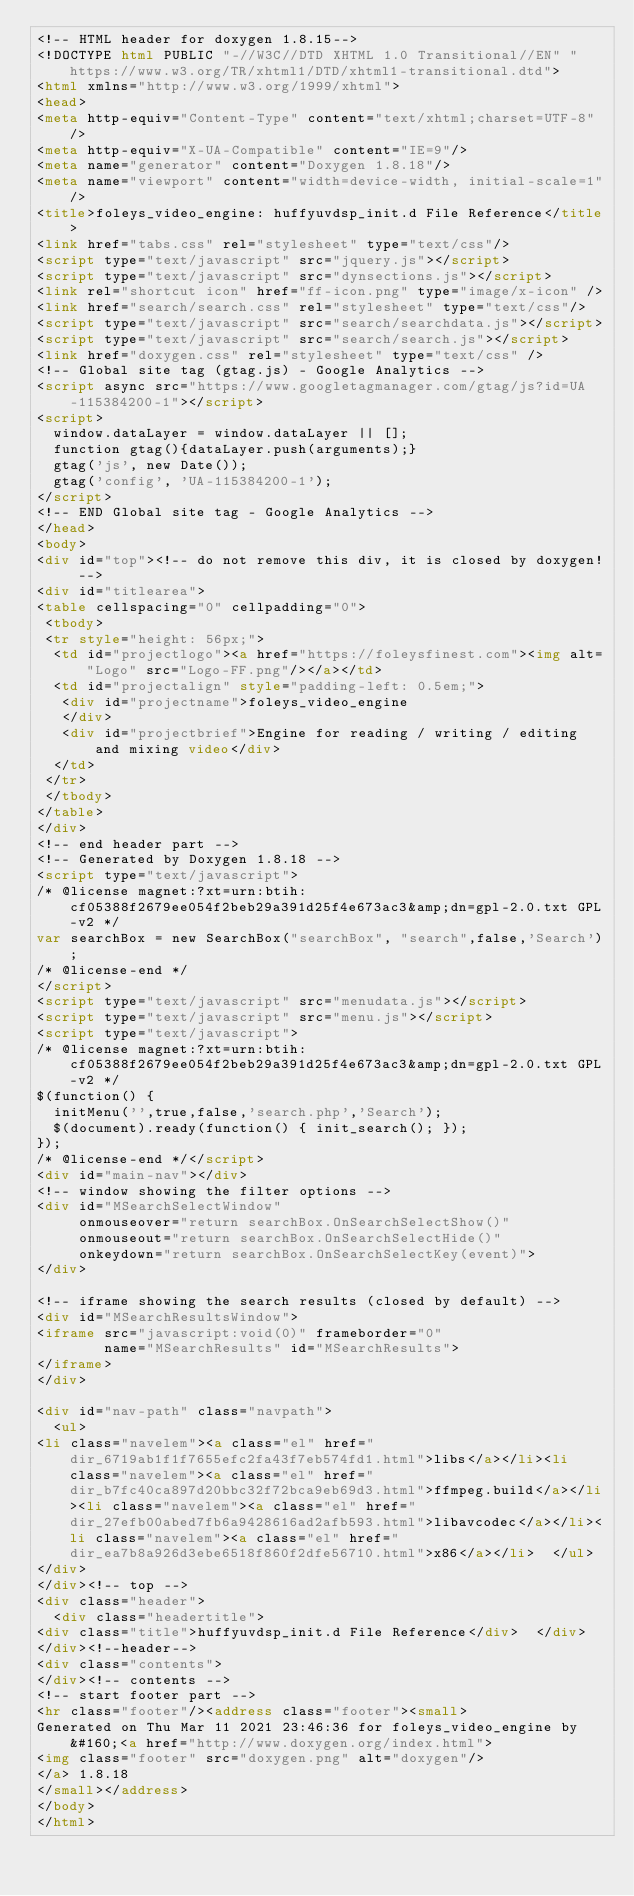Convert code to text. <code><loc_0><loc_0><loc_500><loc_500><_HTML_><!-- HTML header for doxygen 1.8.15-->
<!DOCTYPE html PUBLIC "-//W3C//DTD XHTML 1.0 Transitional//EN" "https://www.w3.org/TR/xhtml1/DTD/xhtml1-transitional.dtd">
<html xmlns="http://www.w3.org/1999/xhtml">
<head>
<meta http-equiv="Content-Type" content="text/xhtml;charset=UTF-8"/>
<meta http-equiv="X-UA-Compatible" content="IE=9"/>
<meta name="generator" content="Doxygen 1.8.18"/>
<meta name="viewport" content="width=device-width, initial-scale=1"/>
<title>foleys_video_engine: huffyuvdsp_init.d File Reference</title>
<link href="tabs.css" rel="stylesheet" type="text/css"/>
<script type="text/javascript" src="jquery.js"></script>
<script type="text/javascript" src="dynsections.js"></script>
<link rel="shortcut icon" href="ff-icon.png" type="image/x-icon" />
<link href="search/search.css" rel="stylesheet" type="text/css"/>
<script type="text/javascript" src="search/searchdata.js"></script>
<script type="text/javascript" src="search/search.js"></script>
<link href="doxygen.css" rel="stylesheet" type="text/css" />
<!-- Global site tag (gtag.js) - Google Analytics -->
<script async src="https://www.googletagmanager.com/gtag/js?id=UA-115384200-1"></script>
<script>
  window.dataLayer = window.dataLayer || [];
  function gtag(){dataLayer.push(arguments);}
  gtag('js', new Date());
  gtag('config', 'UA-115384200-1');
</script>
<!-- END Global site tag - Google Analytics -->
</head>
<body>
<div id="top"><!-- do not remove this div, it is closed by doxygen! -->
<div id="titlearea">
<table cellspacing="0" cellpadding="0">
 <tbody>
 <tr style="height: 56px;">
  <td id="projectlogo"><a href="https://foleysfinest.com"><img alt="Logo" src="Logo-FF.png"/></a></td>
  <td id="projectalign" style="padding-left: 0.5em;">
   <div id="projectname">foleys_video_engine
   </div>
   <div id="projectbrief">Engine for reading / writing / editing and mixing video</div>
  </td>
 </tr>
 </tbody>
</table>
</div>
<!-- end header part -->
<!-- Generated by Doxygen 1.8.18 -->
<script type="text/javascript">
/* @license magnet:?xt=urn:btih:cf05388f2679ee054f2beb29a391d25f4e673ac3&amp;dn=gpl-2.0.txt GPL-v2 */
var searchBox = new SearchBox("searchBox", "search",false,'Search');
/* @license-end */
</script>
<script type="text/javascript" src="menudata.js"></script>
<script type="text/javascript" src="menu.js"></script>
<script type="text/javascript">
/* @license magnet:?xt=urn:btih:cf05388f2679ee054f2beb29a391d25f4e673ac3&amp;dn=gpl-2.0.txt GPL-v2 */
$(function() {
  initMenu('',true,false,'search.php','Search');
  $(document).ready(function() { init_search(); });
});
/* @license-end */</script>
<div id="main-nav"></div>
<!-- window showing the filter options -->
<div id="MSearchSelectWindow"
     onmouseover="return searchBox.OnSearchSelectShow()"
     onmouseout="return searchBox.OnSearchSelectHide()"
     onkeydown="return searchBox.OnSearchSelectKey(event)">
</div>

<!-- iframe showing the search results (closed by default) -->
<div id="MSearchResultsWindow">
<iframe src="javascript:void(0)" frameborder="0" 
        name="MSearchResults" id="MSearchResults">
</iframe>
</div>

<div id="nav-path" class="navpath">
  <ul>
<li class="navelem"><a class="el" href="dir_6719ab1f1f7655efc2fa43f7eb574fd1.html">libs</a></li><li class="navelem"><a class="el" href="dir_b7fc40ca897d20bbc32f72bca9eb69d3.html">ffmpeg.build</a></li><li class="navelem"><a class="el" href="dir_27efb00abed7fb6a9428616ad2afb593.html">libavcodec</a></li><li class="navelem"><a class="el" href="dir_ea7b8a926d3ebe6518f860f2dfe56710.html">x86</a></li>  </ul>
</div>
</div><!-- top -->
<div class="header">
  <div class="headertitle">
<div class="title">huffyuvdsp_init.d File Reference</div>  </div>
</div><!--header-->
<div class="contents">
</div><!-- contents -->
<!-- start footer part -->
<hr class="footer"/><address class="footer"><small>
Generated on Thu Mar 11 2021 23:46:36 for foleys_video_engine by &#160;<a href="http://www.doxygen.org/index.html">
<img class="footer" src="doxygen.png" alt="doxygen"/>
</a> 1.8.18
</small></address>
</body>
</html>
</code> 